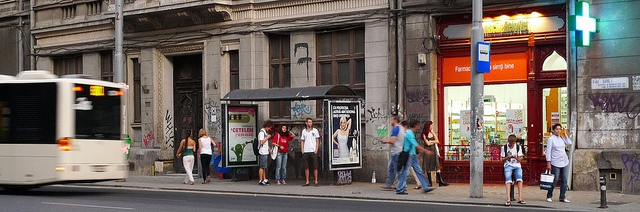Describe the objects in this image and their specific colors. I can see bus in darkgray, black, and lightgray tones, people in darkgray, lavender, black, and gray tones, people in darkgray, black, lavender, and maroon tones, people in darkgray, gray, and navy tones, and people in darkgray, gray, blue, and black tones in this image. 